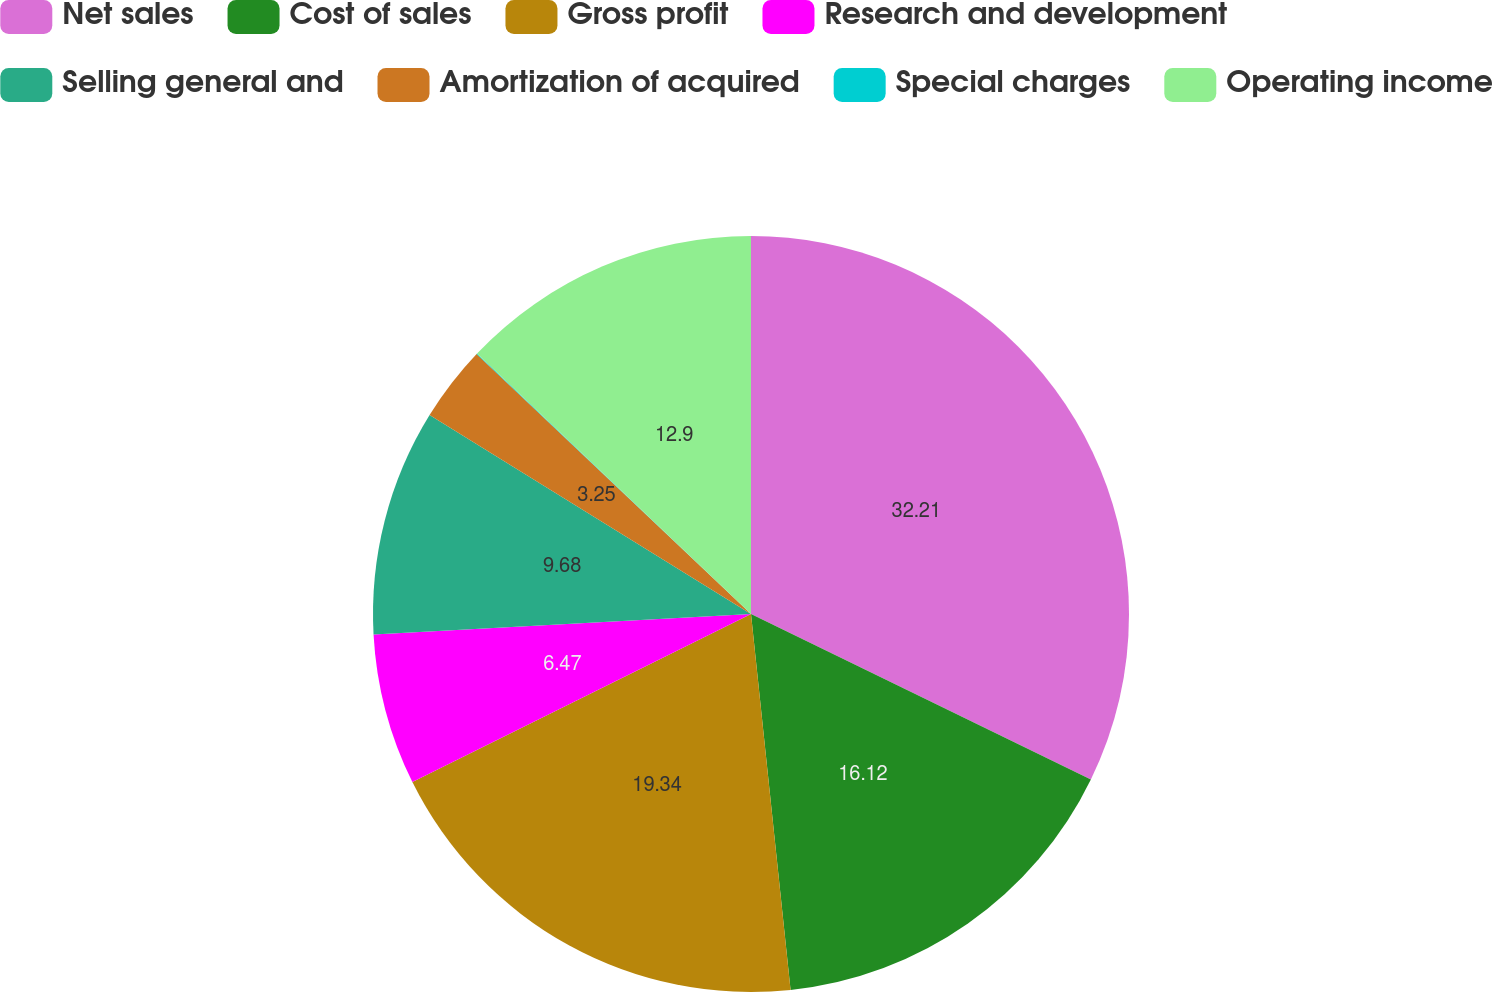Convert chart to OTSL. <chart><loc_0><loc_0><loc_500><loc_500><pie_chart><fcel>Net sales<fcel>Cost of sales<fcel>Gross profit<fcel>Research and development<fcel>Selling general and<fcel>Amortization of acquired<fcel>Special charges<fcel>Operating income<nl><fcel>32.21%<fcel>16.12%<fcel>19.34%<fcel>6.47%<fcel>9.68%<fcel>3.25%<fcel>0.03%<fcel>12.9%<nl></chart> 